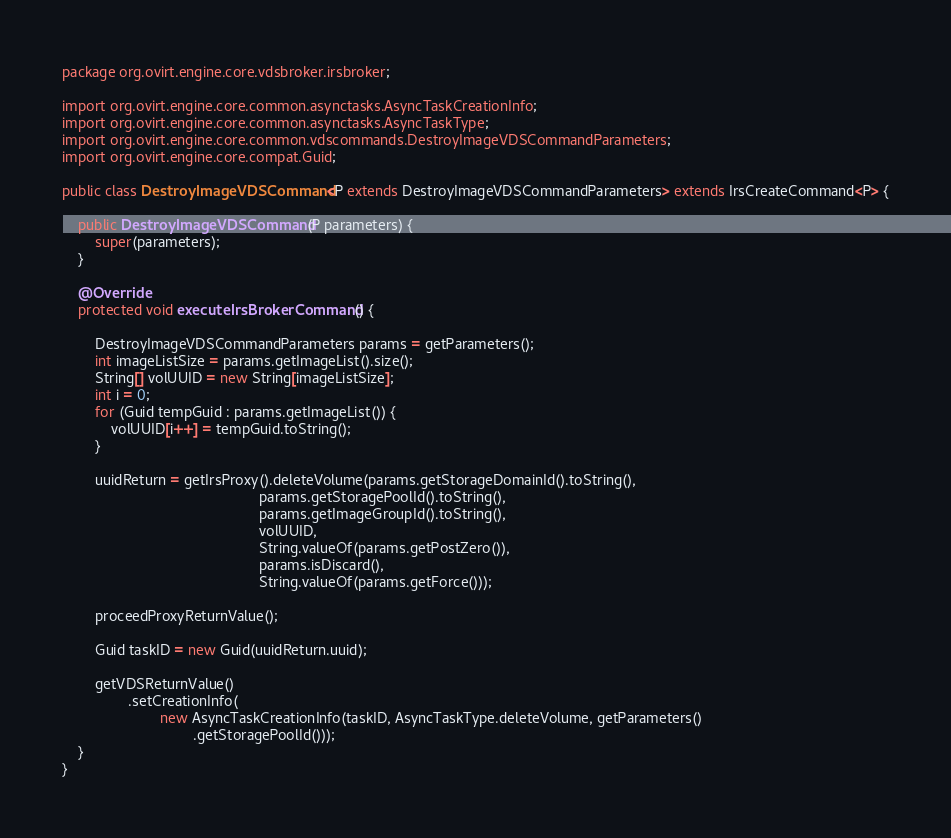<code> <loc_0><loc_0><loc_500><loc_500><_Java_>package org.ovirt.engine.core.vdsbroker.irsbroker;

import org.ovirt.engine.core.common.asynctasks.AsyncTaskCreationInfo;
import org.ovirt.engine.core.common.asynctasks.AsyncTaskType;
import org.ovirt.engine.core.common.vdscommands.DestroyImageVDSCommandParameters;
import org.ovirt.engine.core.compat.Guid;

public class DestroyImageVDSCommand<P extends DestroyImageVDSCommandParameters> extends IrsCreateCommand<P> {

    public DestroyImageVDSCommand(P parameters) {
        super(parameters);
    }

    @Override
    protected void executeIrsBrokerCommand() {

        DestroyImageVDSCommandParameters params = getParameters();
        int imageListSize = params.getImageList().size();
        String[] volUUID = new String[imageListSize];
        int i = 0;
        for (Guid tempGuid : params.getImageList()) {
            volUUID[i++] = tempGuid.toString();
        }

        uuidReturn = getIrsProxy().deleteVolume(params.getStorageDomainId().toString(),
                                                params.getStoragePoolId().toString(),
                                                params.getImageGroupId().toString(),
                                                volUUID,
                                                String.valueOf(params.getPostZero()),
                                                params.isDiscard(),
                                                String.valueOf(params.getForce()));

        proceedProxyReturnValue();

        Guid taskID = new Guid(uuidReturn.uuid);

        getVDSReturnValue()
                .setCreationInfo(
                        new AsyncTaskCreationInfo(taskID, AsyncTaskType.deleteVolume, getParameters()
                                .getStoragePoolId()));
    }
}
</code> 